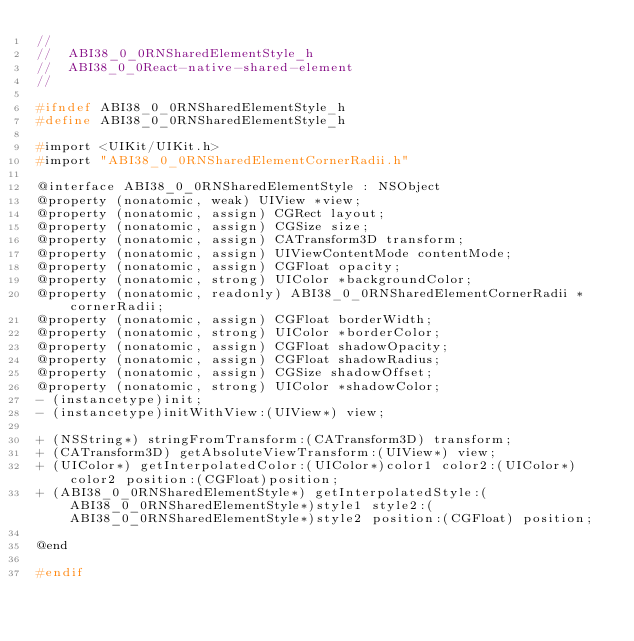<code> <loc_0><loc_0><loc_500><loc_500><_C_>//
//  ABI38_0_0RNSharedElementStyle_h
//  ABI38_0_0React-native-shared-element
//

#ifndef ABI38_0_0RNSharedElementStyle_h
#define ABI38_0_0RNSharedElementStyle_h

#import <UIKit/UIKit.h>
#import "ABI38_0_0RNSharedElementCornerRadii.h"

@interface ABI38_0_0RNSharedElementStyle : NSObject
@property (nonatomic, weak) UIView *view;
@property (nonatomic, assign) CGRect layout;
@property (nonatomic, assign) CGSize size;
@property (nonatomic, assign) CATransform3D transform;
@property (nonatomic, assign) UIViewContentMode contentMode;
@property (nonatomic, assign) CGFloat opacity;
@property (nonatomic, strong) UIColor *backgroundColor;
@property (nonatomic, readonly) ABI38_0_0RNSharedElementCornerRadii *cornerRadii;
@property (nonatomic, assign) CGFloat borderWidth;
@property (nonatomic, strong) UIColor *borderColor;
@property (nonatomic, assign) CGFloat shadowOpacity;
@property (nonatomic, assign) CGFloat shadowRadius;
@property (nonatomic, assign) CGSize shadowOffset;
@property (nonatomic, strong) UIColor *shadowColor;
- (instancetype)init;
- (instancetype)initWithView:(UIView*) view;

+ (NSString*) stringFromTransform:(CATransform3D) transform;
+ (CATransform3D) getAbsoluteViewTransform:(UIView*) view;
+ (UIColor*) getInterpolatedColor:(UIColor*)color1 color2:(UIColor*)color2 position:(CGFloat)position;
+ (ABI38_0_0RNSharedElementStyle*) getInterpolatedStyle:(ABI38_0_0RNSharedElementStyle*)style1 style2:(ABI38_0_0RNSharedElementStyle*)style2 position:(CGFloat) position;

@end

#endif
</code> 